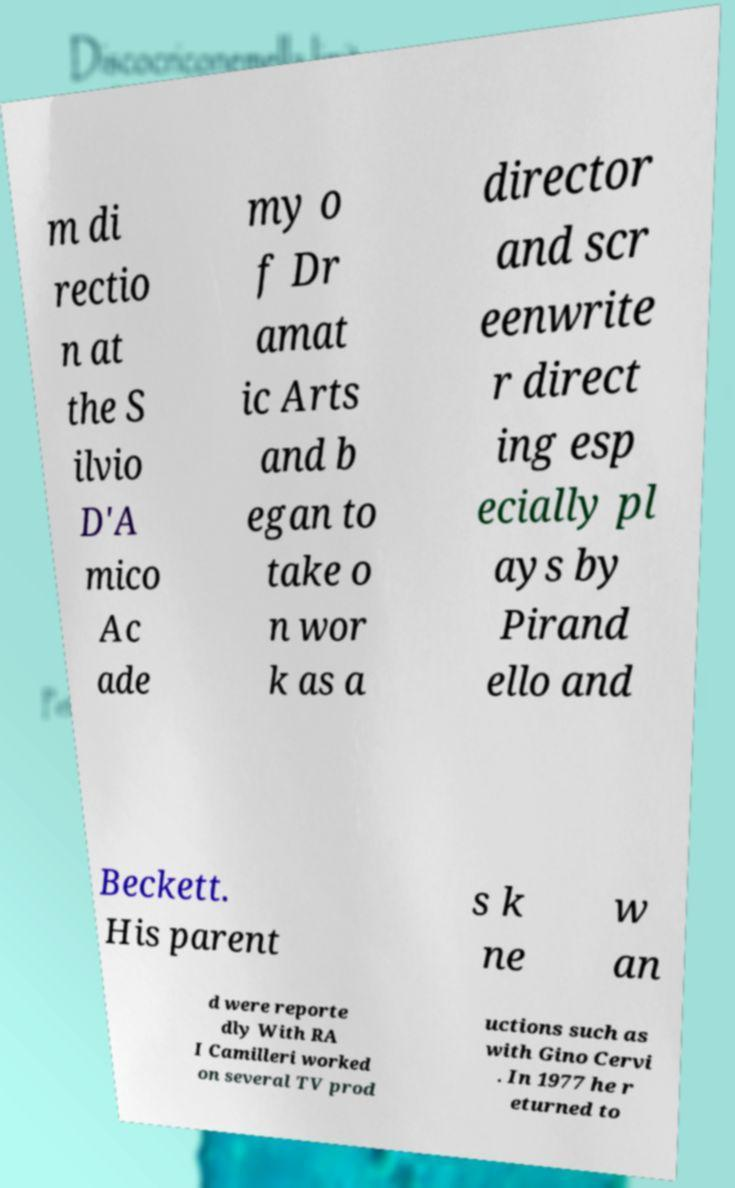For documentation purposes, I need the text within this image transcribed. Could you provide that? m di rectio n at the S ilvio D'A mico Ac ade my o f Dr amat ic Arts and b egan to take o n wor k as a director and scr eenwrite r direct ing esp ecially pl ays by Pirand ello and Beckett. His parent s k ne w an d were reporte dly With RA I Camilleri worked on several TV prod uctions such as with Gino Cervi . In 1977 he r eturned to 